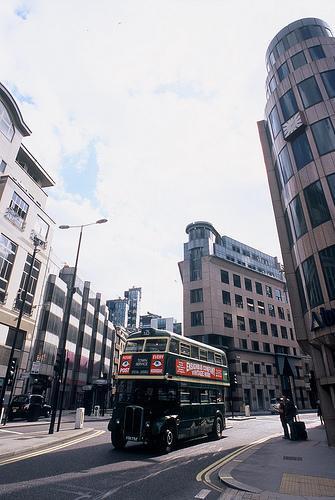How many elephants are pictured?
Give a very brief answer. 0. 